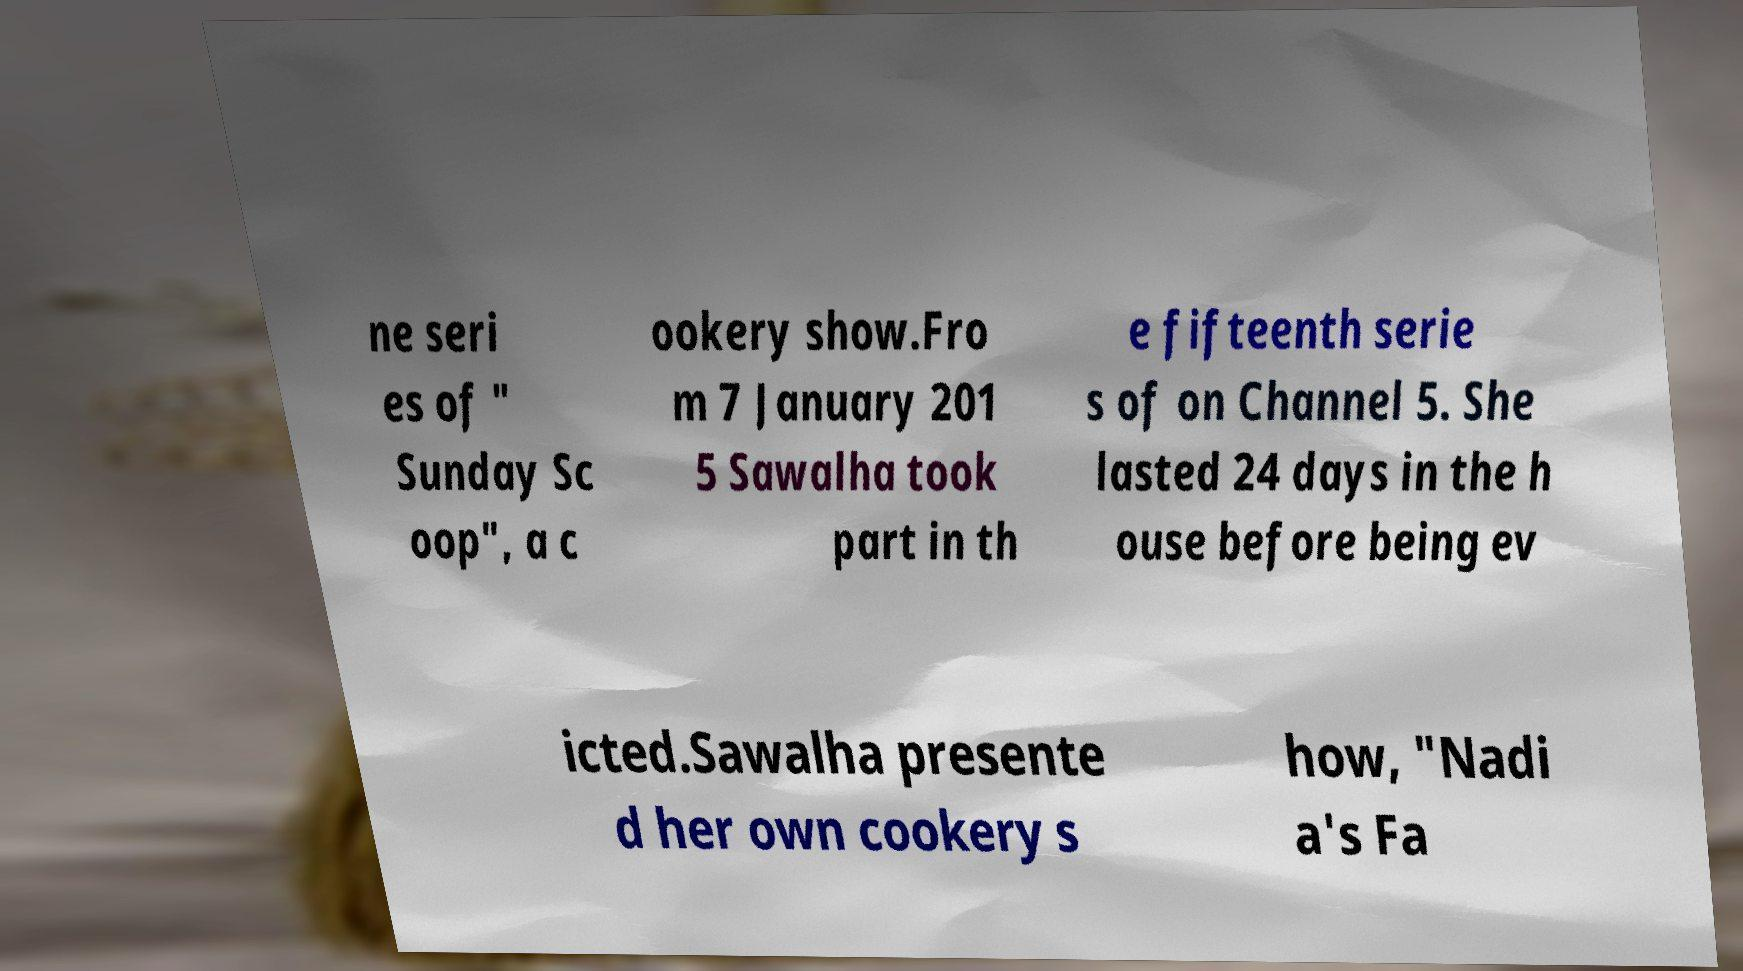There's text embedded in this image that I need extracted. Can you transcribe it verbatim? ne seri es of " Sunday Sc oop", a c ookery show.Fro m 7 January 201 5 Sawalha took part in th e fifteenth serie s of on Channel 5. She lasted 24 days in the h ouse before being ev icted.Sawalha presente d her own cookery s how, "Nadi a's Fa 